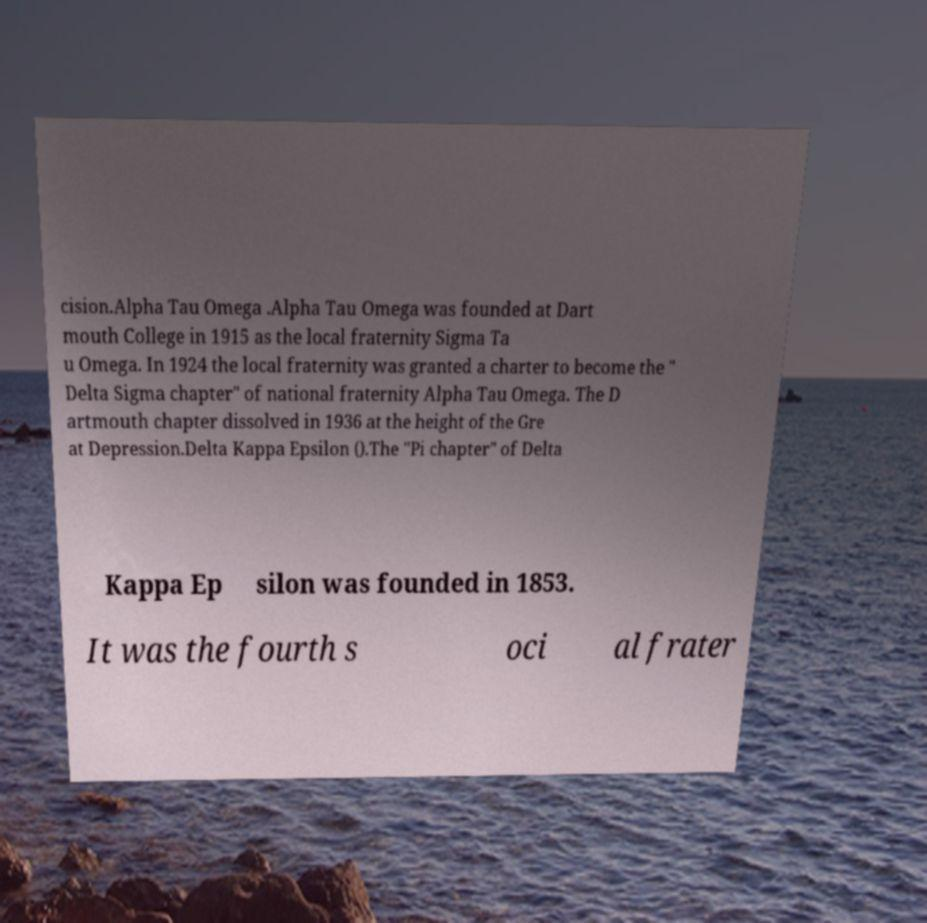Please identify and transcribe the text found in this image. cision.Alpha Tau Omega .Alpha Tau Omega was founded at Dart mouth College in 1915 as the local fraternity Sigma Ta u Omega. In 1924 the local fraternity was granted a charter to become the " Delta Sigma chapter" of national fraternity Alpha Tau Omega. The D artmouth chapter dissolved in 1936 at the height of the Gre at Depression.Delta Kappa Epsilon ().The "Pi chapter" of Delta Kappa Ep silon was founded in 1853. It was the fourth s oci al frater 